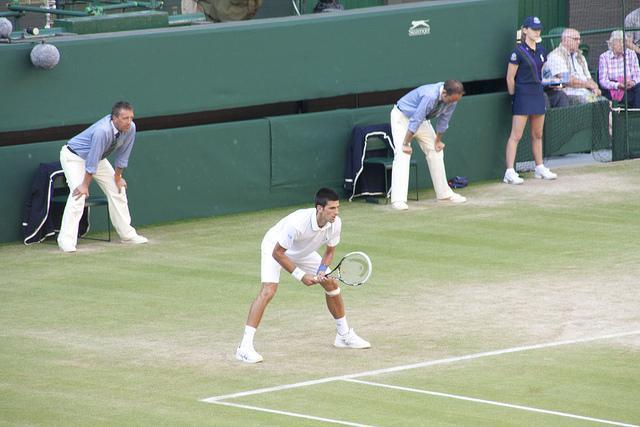How many people are in the photo?
Give a very brief answer. 6. How many train cars are under the poles?
Give a very brief answer. 0. 